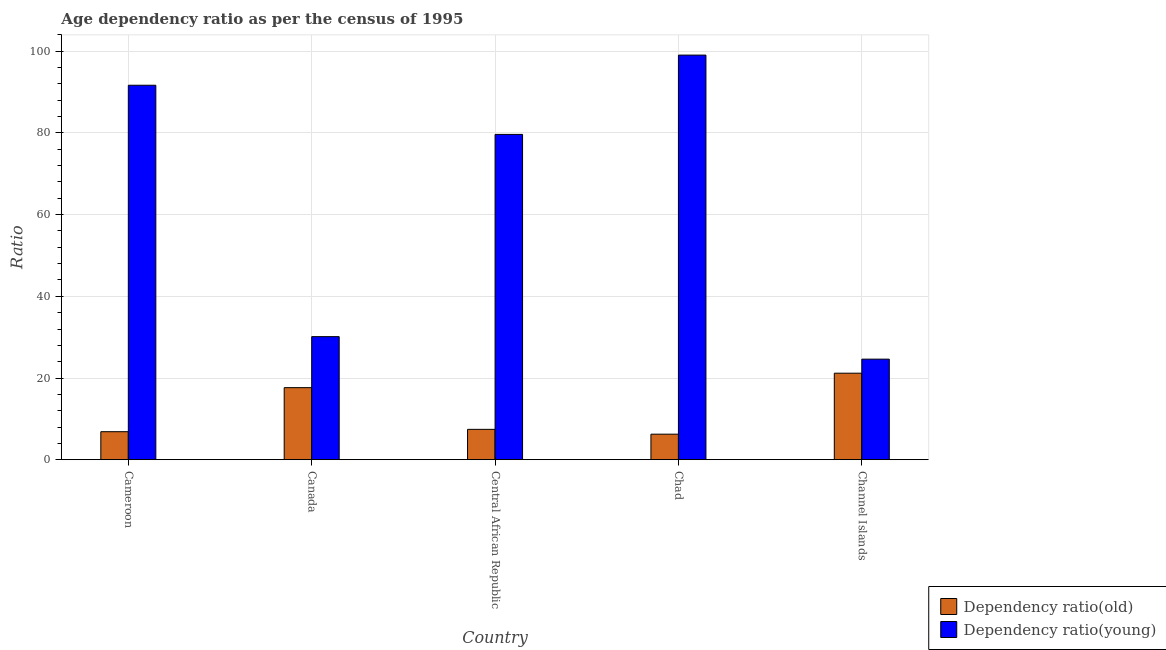How many different coloured bars are there?
Offer a very short reply. 2. How many groups of bars are there?
Provide a short and direct response. 5. Are the number of bars per tick equal to the number of legend labels?
Offer a terse response. Yes. Are the number of bars on each tick of the X-axis equal?
Your response must be concise. Yes. How many bars are there on the 5th tick from the left?
Provide a succinct answer. 2. What is the label of the 1st group of bars from the left?
Your response must be concise. Cameroon. In how many cases, is the number of bars for a given country not equal to the number of legend labels?
Provide a succinct answer. 0. What is the age dependency ratio(old) in Cameroon?
Offer a terse response. 6.86. Across all countries, what is the maximum age dependency ratio(old)?
Make the answer very short. 21.18. Across all countries, what is the minimum age dependency ratio(young)?
Provide a short and direct response. 24.62. In which country was the age dependency ratio(young) maximum?
Offer a very short reply. Chad. In which country was the age dependency ratio(old) minimum?
Offer a terse response. Chad. What is the total age dependency ratio(young) in the graph?
Make the answer very short. 325.14. What is the difference between the age dependency ratio(young) in Central African Republic and that in Chad?
Offer a very short reply. -19.41. What is the difference between the age dependency ratio(young) in Chad and the age dependency ratio(old) in Channel Islands?
Make the answer very short. 77.88. What is the average age dependency ratio(old) per country?
Your answer should be compact. 11.87. What is the difference between the age dependency ratio(old) and age dependency ratio(young) in Central African Republic?
Your answer should be compact. -72.22. What is the ratio of the age dependency ratio(young) in Canada to that in Channel Islands?
Provide a short and direct response. 1.22. Is the difference between the age dependency ratio(young) in Cameroon and Chad greater than the difference between the age dependency ratio(old) in Cameroon and Chad?
Give a very brief answer. No. What is the difference between the highest and the second highest age dependency ratio(young)?
Give a very brief answer. 7.38. What is the difference between the highest and the lowest age dependency ratio(old)?
Your answer should be very brief. 14.93. In how many countries, is the age dependency ratio(young) greater than the average age dependency ratio(young) taken over all countries?
Make the answer very short. 3. Is the sum of the age dependency ratio(young) in Cameroon and Central African Republic greater than the maximum age dependency ratio(old) across all countries?
Your answer should be compact. Yes. What does the 2nd bar from the left in Canada represents?
Your response must be concise. Dependency ratio(young). What does the 1st bar from the right in Canada represents?
Provide a short and direct response. Dependency ratio(young). Are all the bars in the graph horizontal?
Make the answer very short. No. How many countries are there in the graph?
Make the answer very short. 5. Are the values on the major ticks of Y-axis written in scientific E-notation?
Provide a succinct answer. No. Where does the legend appear in the graph?
Your answer should be compact. Bottom right. What is the title of the graph?
Give a very brief answer. Age dependency ratio as per the census of 1995. Does "Male population" appear as one of the legend labels in the graph?
Your answer should be compact. No. What is the label or title of the Y-axis?
Provide a short and direct response. Ratio. What is the Ratio of Dependency ratio(old) in Cameroon?
Ensure brevity in your answer.  6.86. What is the Ratio in Dependency ratio(young) in Cameroon?
Provide a short and direct response. 91.68. What is the Ratio in Dependency ratio(old) in Canada?
Your answer should be very brief. 17.64. What is the Ratio in Dependency ratio(young) in Canada?
Your answer should be very brief. 30.13. What is the Ratio of Dependency ratio(old) in Central African Republic?
Provide a short and direct response. 7.43. What is the Ratio of Dependency ratio(young) in Central African Republic?
Ensure brevity in your answer.  79.65. What is the Ratio of Dependency ratio(old) in Chad?
Keep it short and to the point. 6.25. What is the Ratio in Dependency ratio(young) in Chad?
Offer a terse response. 99.06. What is the Ratio of Dependency ratio(old) in Channel Islands?
Offer a terse response. 21.18. What is the Ratio in Dependency ratio(young) in Channel Islands?
Your answer should be compact. 24.62. Across all countries, what is the maximum Ratio of Dependency ratio(old)?
Provide a succinct answer. 21.18. Across all countries, what is the maximum Ratio in Dependency ratio(young)?
Offer a terse response. 99.06. Across all countries, what is the minimum Ratio in Dependency ratio(old)?
Offer a very short reply. 6.25. Across all countries, what is the minimum Ratio of Dependency ratio(young)?
Provide a succinct answer. 24.62. What is the total Ratio in Dependency ratio(old) in the graph?
Your response must be concise. 59.36. What is the total Ratio of Dependency ratio(young) in the graph?
Ensure brevity in your answer.  325.14. What is the difference between the Ratio of Dependency ratio(old) in Cameroon and that in Canada?
Provide a succinct answer. -10.78. What is the difference between the Ratio of Dependency ratio(young) in Cameroon and that in Canada?
Offer a terse response. 61.56. What is the difference between the Ratio in Dependency ratio(old) in Cameroon and that in Central African Republic?
Your answer should be very brief. -0.58. What is the difference between the Ratio in Dependency ratio(young) in Cameroon and that in Central African Republic?
Make the answer very short. 12.03. What is the difference between the Ratio in Dependency ratio(old) in Cameroon and that in Chad?
Provide a short and direct response. 0.61. What is the difference between the Ratio of Dependency ratio(young) in Cameroon and that in Chad?
Keep it short and to the point. -7.38. What is the difference between the Ratio of Dependency ratio(old) in Cameroon and that in Channel Islands?
Offer a very short reply. -14.32. What is the difference between the Ratio in Dependency ratio(young) in Cameroon and that in Channel Islands?
Keep it short and to the point. 67.06. What is the difference between the Ratio of Dependency ratio(old) in Canada and that in Central African Republic?
Provide a short and direct response. 10.21. What is the difference between the Ratio of Dependency ratio(young) in Canada and that in Central African Republic?
Make the answer very short. -49.52. What is the difference between the Ratio in Dependency ratio(old) in Canada and that in Chad?
Make the answer very short. 11.39. What is the difference between the Ratio of Dependency ratio(young) in Canada and that in Chad?
Your answer should be compact. -68.93. What is the difference between the Ratio in Dependency ratio(old) in Canada and that in Channel Islands?
Make the answer very short. -3.54. What is the difference between the Ratio in Dependency ratio(young) in Canada and that in Channel Islands?
Give a very brief answer. 5.51. What is the difference between the Ratio of Dependency ratio(old) in Central African Republic and that in Chad?
Provide a succinct answer. 1.18. What is the difference between the Ratio of Dependency ratio(young) in Central African Republic and that in Chad?
Give a very brief answer. -19.41. What is the difference between the Ratio of Dependency ratio(old) in Central African Republic and that in Channel Islands?
Offer a terse response. -13.75. What is the difference between the Ratio in Dependency ratio(young) in Central African Republic and that in Channel Islands?
Your response must be concise. 55.03. What is the difference between the Ratio in Dependency ratio(old) in Chad and that in Channel Islands?
Ensure brevity in your answer.  -14.93. What is the difference between the Ratio in Dependency ratio(young) in Chad and that in Channel Islands?
Provide a short and direct response. 74.44. What is the difference between the Ratio of Dependency ratio(old) in Cameroon and the Ratio of Dependency ratio(young) in Canada?
Offer a terse response. -23.27. What is the difference between the Ratio in Dependency ratio(old) in Cameroon and the Ratio in Dependency ratio(young) in Central African Republic?
Your response must be concise. -72.79. What is the difference between the Ratio of Dependency ratio(old) in Cameroon and the Ratio of Dependency ratio(young) in Chad?
Offer a terse response. -92.21. What is the difference between the Ratio of Dependency ratio(old) in Cameroon and the Ratio of Dependency ratio(young) in Channel Islands?
Your answer should be compact. -17.76. What is the difference between the Ratio of Dependency ratio(old) in Canada and the Ratio of Dependency ratio(young) in Central African Republic?
Ensure brevity in your answer.  -62.01. What is the difference between the Ratio of Dependency ratio(old) in Canada and the Ratio of Dependency ratio(young) in Chad?
Provide a short and direct response. -81.42. What is the difference between the Ratio in Dependency ratio(old) in Canada and the Ratio in Dependency ratio(young) in Channel Islands?
Your answer should be very brief. -6.98. What is the difference between the Ratio in Dependency ratio(old) in Central African Republic and the Ratio in Dependency ratio(young) in Chad?
Give a very brief answer. -91.63. What is the difference between the Ratio in Dependency ratio(old) in Central African Republic and the Ratio in Dependency ratio(young) in Channel Islands?
Give a very brief answer. -17.19. What is the difference between the Ratio in Dependency ratio(old) in Chad and the Ratio in Dependency ratio(young) in Channel Islands?
Your answer should be compact. -18.37. What is the average Ratio in Dependency ratio(old) per country?
Your answer should be compact. 11.87. What is the average Ratio of Dependency ratio(young) per country?
Provide a succinct answer. 65.03. What is the difference between the Ratio of Dependency ratio(old) and Ratio of Dependency ratio(young) in Cameroon?
Your answer should be very brief. -84.83. What is the difference between the Ratio in Dependency ratio(old) and Ratio in Dependency ratio(young) in Canada?
Your answer should be compact. -12.49. What is the difference between the Ratio in Dependency ratio(old) and Ratio in Dependency ratio(young) in Central African Republic?
Make the answer very short. -72.22. What is the difference between the Ratio of Dependency ratio(old) and Ratio of Dependency ratio(young) in Chad?
Provide a succinct answer. -92.81. What is the difference between the Ratio in Dependency ratio(old) and Ratio in Dependency ratio(young) in Channel Islands?
Provide a short and direct response. -3.44. What is the ratio of the Ratio in Dependency ratio(old) in Cameroon to that in Canada?
Your answer should be compact. 0.39. What is the ratio of the Ratio in Dependency ratio(young) in Cameroon to that in Canada?
Offer a terse response. 3.04. What is the ratio of the Ratio in Dependency ratio(old) in Cameroon to that in Central African Republic?
Keep it short and to the point. 0.92. What is the ratio of the Ratio of Dependency ratio(young) in Cameroon to that in Central African Republic?
Give a very brief answer. 1.15. What is the ratio of the Ratio in Dependency ratio(old) in Cameroon to that in Chad?
Your response must be concise. 1.1. What is the ratio of the Ratio in Dependency ratio(young) in Cameroon to that in Chad?
Keep it short and to the point. 0.93. What is the ratio of the Ratio of Dependency ratio(old) in Cameroon to that in Channel Islands?
Ensure brevity in your answer.  0.32. What is the ratio of the Ratio of Dependency ratio(young) in Cameroon to that in Channel Islands?
Give a very brief answer. 3.72. What is the ratio of the Ratio in Dependency ratio(old) in Canada to that in Central African Republic?
Give a very brief answer. 2.37. What is the ratio of the Ratio of Dependency ratio(young) in Canada to that in Central African Republic?
Your answer should be compact. 0.38. What is the ratio of the Ratio of Dependency ratio(old) in Canada to that in Chad?
Your answer should be very brief. 2.82. What is the ratio of the Ratio of Dependency ratio(young) in Canada to that in Chad?
Ensure brevity in your answer.  0.3. What is the ratio of the Ratio in Dependency ratio(old) in Canada to that in Channel Islands?
Keep it short and to the point. 0.83. What is the ratio of the Ratio of Dependency ratio(young) in Canada to that in Channel Islands?
Offer a very short reply. 1.22. What is the ratio of the Ratio in Dependency ratio(old) in Central African Republic to that in Chad?
Provide a succinct answer. 1.19. What is the ratio of the Ratio of Dependency ratio(young) in Central African Republic to that in Chad?
Keep it short and to the point. 0.8. What is the ratio of the Ratio in Dependency ratio(old) in Central African Republic to that in Channel Islands?
Make the answer very short. 0.35. What is the ratio of the Ratio of Dependency ratio(young) in Central African Republic to that in Channel Islands?
Ensure brevity in your answer.  3.24. What is the ratio of the Ratio in Dependency ratio(old) in Chad to that in Channel Islands?
Your response must be concise. 0.3. What is the ratio of the Ratio in Dependency ratio(young) in Chad to that in Channel Islands?
Your response must be concise. 4.02. What is the difference between the highest and the second highest Ratio in Dependency ratio(old)?
Keep it short and to the point. 3.54. What is the difference between the highest and the second highest Ratio of Dependency ratio(young)?
Keep it short and to the point. 7.38. What is the difference between the highest and the lowest Ratio in Dependency ratio(old)?
Make the answer very short. 14.93. What is the difference between the highest and the lowest Ratio in Dependency ratio(young)?
Your response must be concise. 74.44. 